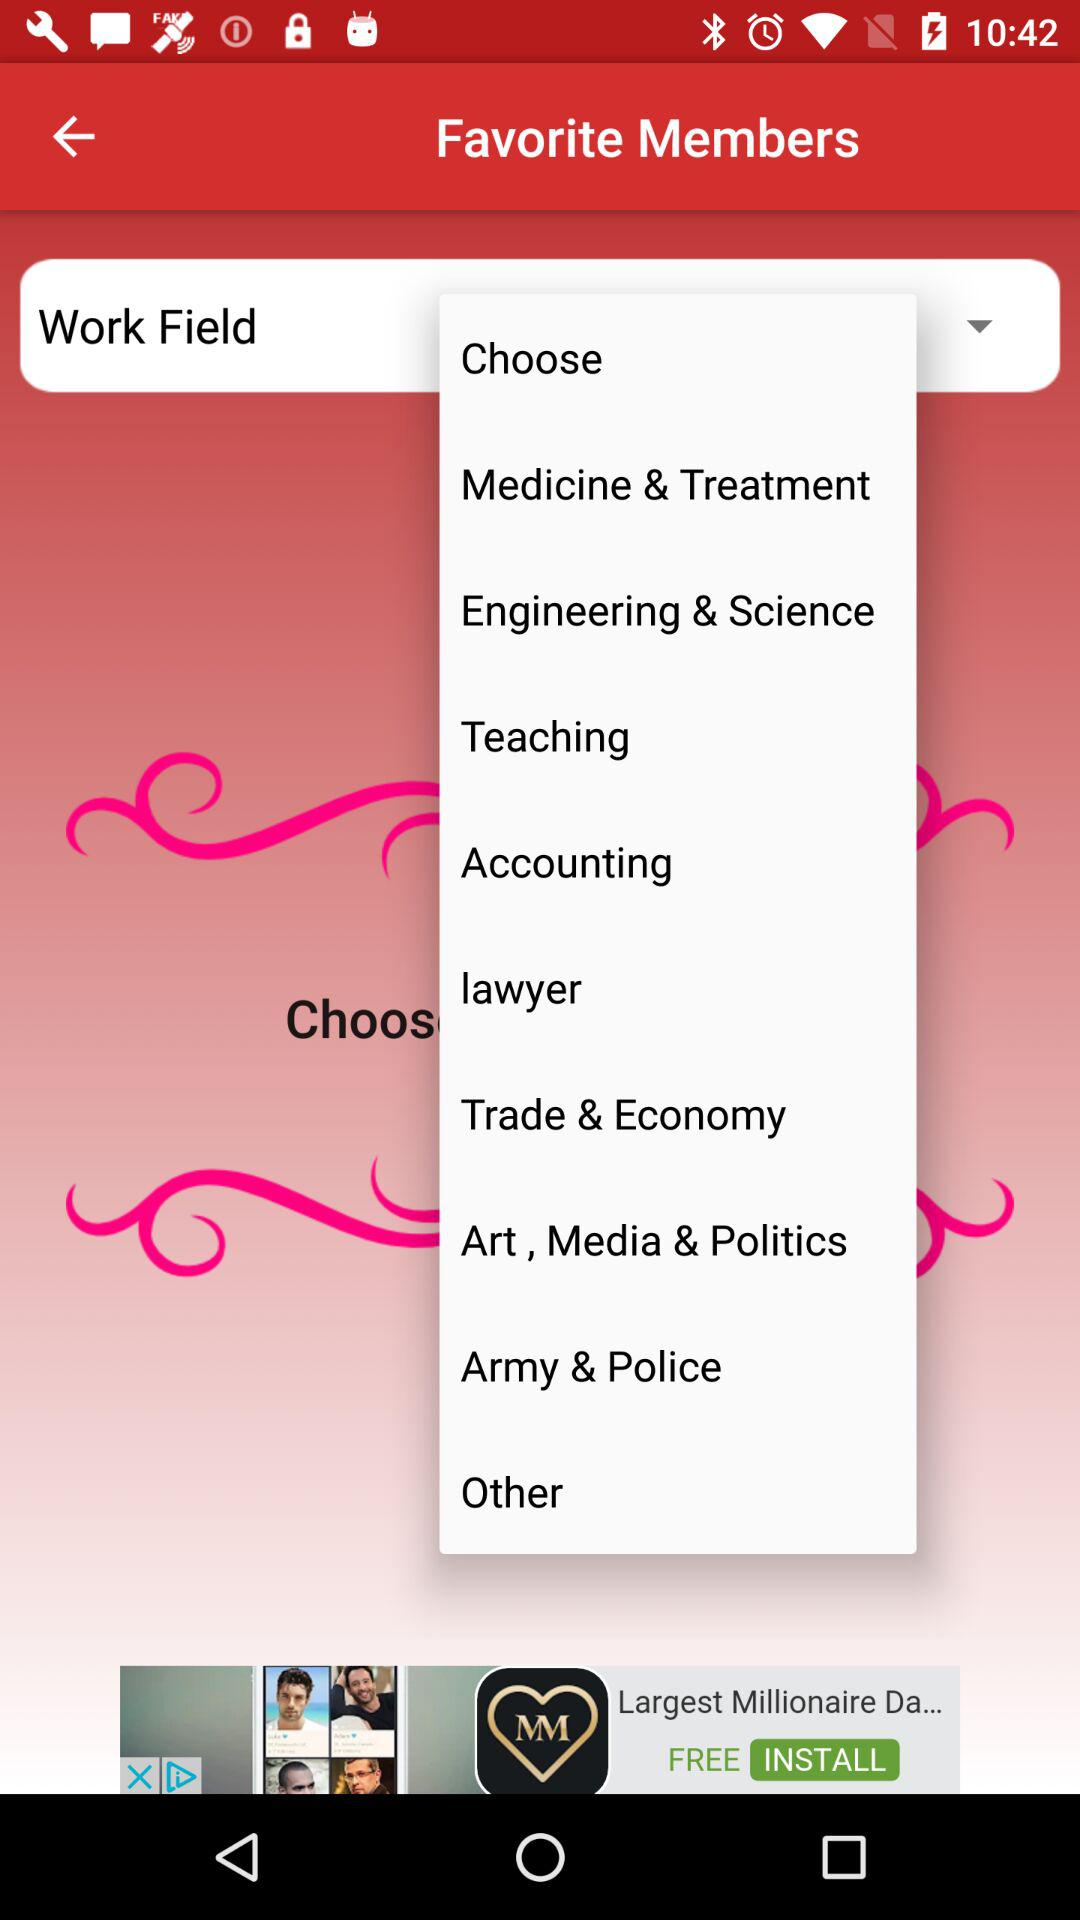How many notifications are there in "Other"?
When the provided information is insufficient, respond with <no answer>. <no answer> 